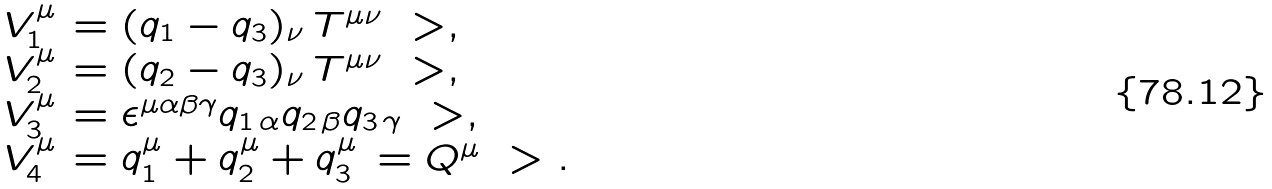Convert formula to latex. <formula><loc_0><loc_0><loc_500><loc_500>\begin{array} { l l } V _ { 1 } ^ { \mu } & = ( q _ { 1 } - q _ { 3 } ) _ { \nu } \, T ^ { \mu \nu } \ > , \\ V _ { 2 } ^ { \mu } & = ( q _ { 2 } - q _ { 3 } ) _ { \nu } \, T ^ { \mu \nu } \ > , \\ V _ { 3 } ^ { \mu } & = \epsilon ^ { \mu \alpha \beta \gamma } q _ { 1 \, \alpha } q _ { 2 \, \beta } q _ { 3 \, \gamma } \ > , \\ V _ { 4 } ^ { \mu } & = q _ { 1 } ^ { \mu } + q _ { 2 } ^ { \mu } + q _ { 3 } ^ { \mu } \, = Q ^ { \mu } \ > . \end{array}</formula> 